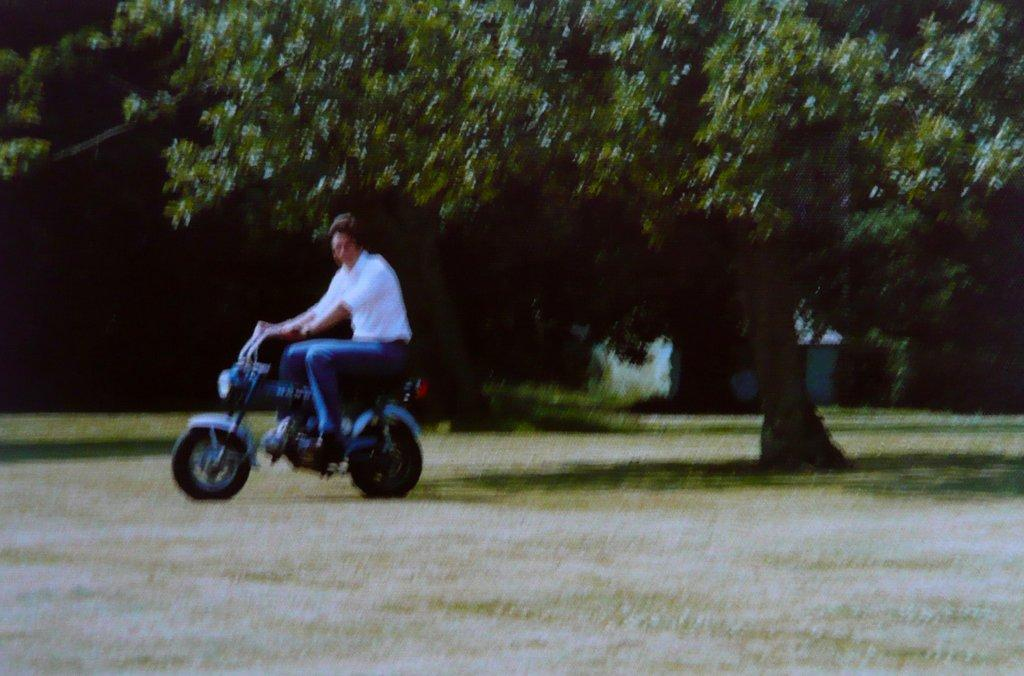Who is present in the image? There is a man in the image. What is the man wearing? The man is wearing a white shirt. What is the man doing in the image? The man is riding a motorbike. What can be seen in the distance in the image? There are trees and plants in the distance. What channel is the man watching on the motorbike? There is no television or channel present in the image; the man is riding a motorbike. 